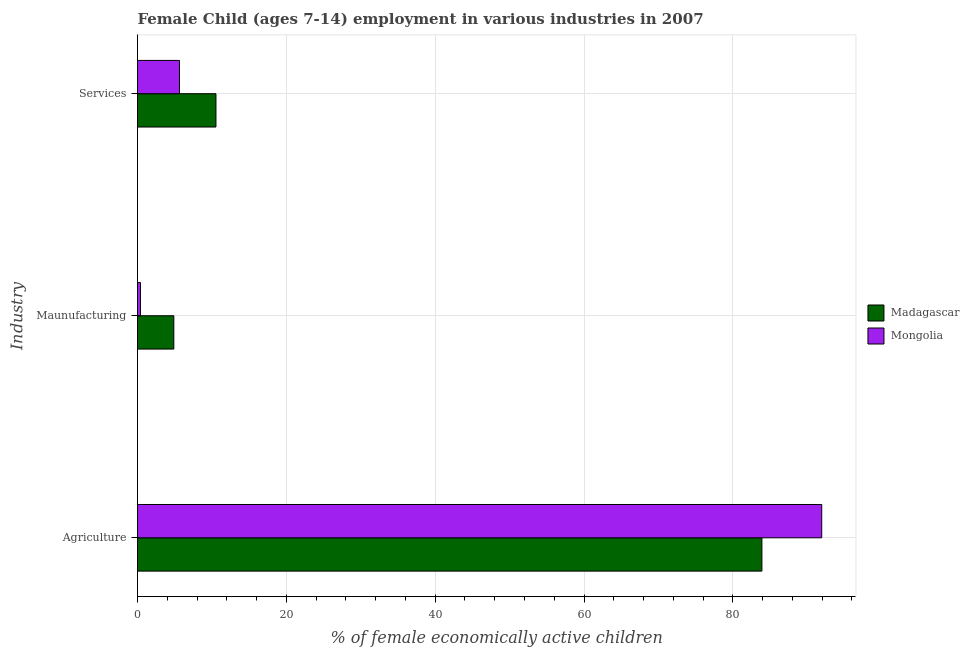How many groups of bars are there?
Your response must be concise. 3. How many bars are there on the 2nd tick from the bottom?
Your answer should be compact. 2. What is the label of the 1st group of bars from the top?
Give a very brief answer. Services. What is the percentage of economically active children in services in Mongolia?
Your answer should be compact. 5.64. Across all countries, what is the maximum percentage of economically active children in services?
Ensure brevity in your answer.  10.54. In which country was the percentage of economically active children in agriculture maximum?
Give a very brief answer. Mongolia. In which country was the percentage of economically active children in services minimum?
Provide a short and direct response. Mongolia. What is the total percentage of economically active children in agriculture in the graph?
Your answer should be compact. 175.84. What is the difference between the percentage of economically active children in agriculture in Madagascar and that in Mongolia?
Provide a short and direct response. -8.04. What is the difference between the percentage of economically active children in agriculture in Mongolia and the percentage of economically active children in services in Madagascar?
Keep it short and to the point. 81.4. What is the average percentage of economically active children in manufacturing per country?
Offer a very short reply. 2.64. What is the difference between the percentage of economically active children in services and percentage of economically active children in agriculture in Mongolia?
Keep it short and to the point. -86.3. In how many countries, is the percentage of economically active children in manufacturing greater than 16 %?
Ensure brevity in your answer.  0. Is the percentage of economically active children in agriculture in Madagascar less than that in Mongolia?
Provide a short and direct response. Yes. What is the difference between the highest and the second highest percentage of economically active children in services?
Your answer should be compact. 4.9. What is the difference between the highest and the lowest percentage of economically active children in services?
Give a very brief answer. 4.9. In how many countries, is the percentage of economically active children in agriculture greater than the average percentage of economically active children in agriculture taken over all countries?
Your answer should be very brief. 1. Is the sum of the percentage of economically active children in agriculture in Mongolia and Madagascar greater than the maximum percentage of economically active children in manufacturing across all countries?
Give a very brief answer. Yes. What does the 1st bar from the top in Maunufacturing represents?
Your answer should be very brief. Mongolia. What does the 1st bar from the bottom in Services represents?
Your answer should be compact. Madagascar. Is it the case that in every country, the sum of the percentage of economically active children in agriculture and percentage of economically active children in manufacturing is greater than the percentage of economically active children in services?
Give a very brief answer. Yes. How many bars are there?
Your response must be concise. 6. Are the values on the major ticks of X-axis written in scientific E-notation?
Your response must be concise. No. How many legend labels are there?
Keep it short and to the point. 2. How are the legend labels stacked?
Give a very brief answer. Vertical. What is the title of the graph?
Your answer should be very brief. Female Child (ages 7-14) employment in various industries in 2007. What is the label or title of the X-axis?
Ensure brevity in your answer.  % of female economically active children. What is the label or title of the Y-axis?
Your answer should be very brief. Industry. What is the % of female economically active children of Madagascar in Agriculture?
Your answer should be very brief. 83.9. What is the % of female economically active children in Mongolia in Agriculture?
Provide a short and direct response. 91.94. What is the % of female economically active children of Madagascar in Maunufacturing?
Give a very brief answer. 4.88. What is the % of female economically active children of Madagascar in Services?
Give a very brief answer. 10.54. What is the % of female economically active children in Mongolia in Services?
Provide a succinct answer. 5.64. Across all Industry, what is the maximum % of female economically active children of Madagascar?
Your response must be concise. 83.9. Across all Industry, what is the maximum % of female economically active children of Mongolia?
Your answer should be compact. 91.94. Across all Industry, what is the minimum % of female economically active children in Madagascar?
Keep it short and to the point. 4.88. What is the total % of female economically active children of Madagascar in the graph?
Give a very brief answer. 99.32. What is the total % of female economically active children in Mongolia in the graph?
Make the answer very short. 97.98. What is the difference between the % of female economically active children of Madagascar in Agriculture and that in Maunufacturing?
Your answer should be very brief. 79.02. What is the difference between the % of female economically active children of Mongolia in Agriculture and that in Maunufacturing?
Your answer should be compact. 91.54. What is the difference between the % of female economically active children of Madagascar in Agriculture and that in Services?
Ensure brevity in your answer.  73.36. What is the difference between the % of female economically active children in Mongolia in Agriculture and that in Services?
Your response must be concise. 86.3. What is the difference between the % of female economically active children in Madagascar in Maunufacturing and that in Services?
Your response must be concise. -5.66. What is the difference between the % of female economically active children in Mongolia in Maunufacturing and that in Services?
Ensure brevity in your answer.  -5.24. What is the difference between the % of female economically active children of Madagascar in Agriculture and the % of female economically active children of Mongolia in Maunufacturing?
Keep it short and to the point. 83.5. What is the difference between the % of female economically active children of Madagascar in Agriculture and the % of female economically active children of Mongolia in Services?
Your answer should be compact. 78.26. What is the difference between the % of female economically active children in Madagascar in Maunufacturing and the % of female economically active children in Mongolia in Services?
Your answer should be compact. -0.76. What is the average % of female economically active children in Madagascar per Industry?
Keep it short and to the point. 33.11. What is the average % of female economically active children in Mongolia per Industry?
Give a very brief answer. 32.66. What is the difference between the % of female economically active children in Madagascar and % of female economically active children in Mongolia in Agriculture?
Your answer should be very brief. -8.04. What is the difference between the % of female economically active children in Madagascar and % of female economically active children in Mongolia in Maunufacturing?
Offer a very short reply. 4.48. What is the difference between the % of female economically active children in Madagascar and % of female economically active children in Mongolia in Services?
Give a very brief answer. 4.9. What is the ratio of the % of female economically active children in Madagascar in Agriculture to that in Maunufacturing?
Offer a very short reply. 17.19. What is the ratio of the % of female economically active children in Mongolia in Agriculture to that in Maunufacturing?
Provide a short and direct response. 229.85. What is the ratio of the % of female economically active children of Madagascar in Agriculture to that in Services?
Your answer should be very brief. 7.96. What is the ratio of the % of female economically active children of Mongolia in Agriculture to that in Services?
Make the answer very short. 16.3. What is the ratio of the % of female economically active children of Madagascar in Maunufacturing to that in Services?
Make the answer very short. 0.46. What is the ratio of the % of female economically active children of Mongolia in Maunufacturing to that in Services?
Ensure brevity in your answer.  0.07. What is the difference between the highest and the second highest % of female economically active children in Madagascar?
Ensure brevity in your answer.  73.36. What is the difference between the highest and the second highest % of female economically active children of Mongolia?
Provide a succinct answer. 86.3. What is the difference between the highest and the lowest % of female economically active children in Madagascar?
Ensure brevity in your answer.  79.02. What is the difference between the highest and the lowest % of female economically active children in Mongolia?
Offer a very short reply. 91.54. 